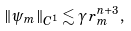<formula> <loc_0><loc_0><loc_500><loc_500>\| \psi _ { m } \| _ { C ^ { 1 } } \lesssim \gamma \, r _ { m } ^ { n + 3 } ,</formula> 